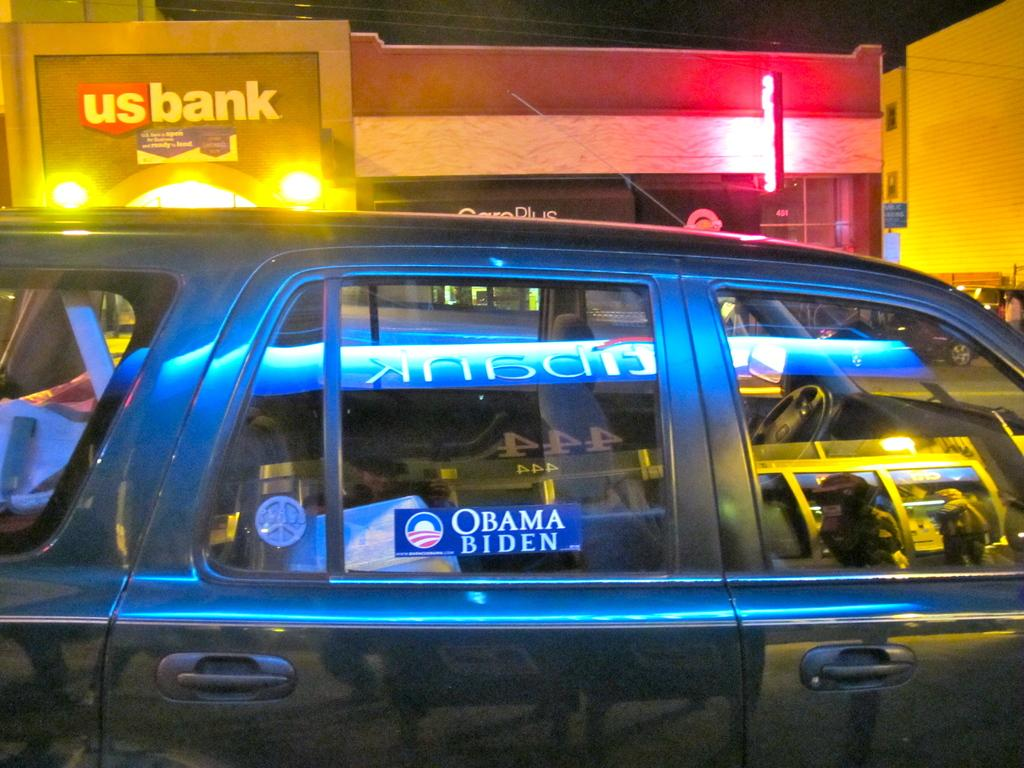Provide a one-sentence caption for the provided image. a suv with a obama biden sticker on the window. 